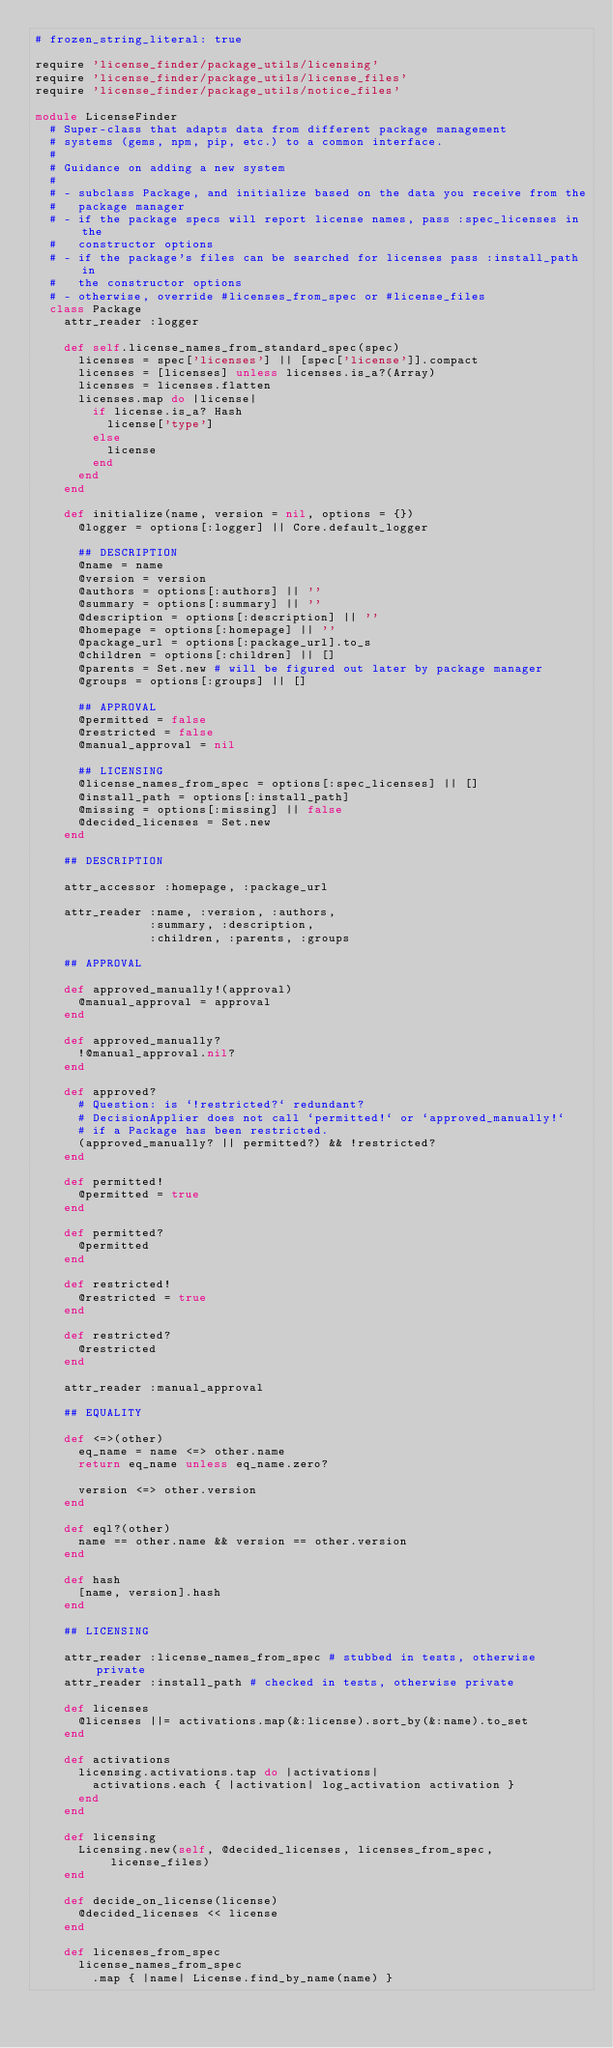Convert code to text. <code><loc_0><loc_0><loc_500><loc_500><_Ruby_># frozen_string_literal: true

require 'license_finder/package_utils/licensing'
require 'license_finder/package_utils/license_files'
require 'license_finder/package_utils/notice_files'

module LicenseFinder
  # Super-class that adapts data from different package management
  # systems (gems, npm, pip, etc.) to a common interface.
  #
  # Guidance on adding a new system
  #
  # - subclass Package, and initialize based on the data you receive from the
  #   package manager
  # - if the package specs will report license names, pass :spec_licenses in the
  #   constructor options
  # - if the package's files can be searched for licenses pass :install_path in
  #   the constructor options
  # - otherwise, override #licenses_from_spec or #license_files
  class Package
    attr_reader :logger

    def self.license_names_from_standard_spec(spec)
      licenses = spec['licenses'] || [spec['license']].compact
      licenses = [licenses] unless licenses.is_a?(Array)
      licenses = licenses.flatten
      licenses.map do |license|
        if license.is_a? Hash
          license['type']
        else
          license
        end
      end
    end

    def initialize(name, version = nil, options = {})
      @logger = options[:logger] || Core.default_logger

      ## DESCRIPTION
      @name = name
      @version = version
      @authors = options[:authors] || ''
      @summary = options[:summary] || ''
      @description = options[:description] || ''
      @homepage = options[:homepage] || ''
      @package_url = options[:package_url].to_s
      @children = options[:children] || []
      @parents = Set.new # will be figured out later by package manager
      @groups = options[:groups] || []

      ## APPROVAL
      @permitted = false
      @restricted = false
      @manual_approval = nil

      ## LICENSING
      @license_names_from_spec = options[:spec_licenses] || []
      @install_path = options[:install_path]
      @missing = options[:missing] || false
      @decided_licenses = Set.new
    end

    ## DESCRIPTION

    attr_accessor :homepage, :package_url

    attr_reader :name, :version, :authors,
                :summary, :description,
                :children, :parents, :groups

    ## APPROVAL

    def approved_manually!(approval)
      @manual_approval = approval
    end

    def approved_manually?
      !@manual_approval.nil?
    end

    def approved?
      # Question: is `!restricted?` redundant?
      # DecisionApplier does not call `permitted!` or `approved_manually!`
      # if a Package has been restricted.
      (approved_manually? || permitted?) && !restricted?
    end

    def permitted!
      @permitted = true
    end

    def permitted?
      @permitted
    end

    def restricted!
      @restricted = true
    end

    def restricted?
      @restricted
    end

    attr_reader :manual_approval

    ## EQUALITY

    def <=>(other)
      eq_name = name <=> other.name
      return eq_name unless eq_name.zero?

      version <=> other.version
    end

    def eql?(other)
      name == other.name && version == other.version
    end

    def hash
      [name, version].hash
    end

    ## LICENSING

    attr_reader :license_names_from_spec # stubbed in tests, otherwise private
    attr_reader :install_path # checked in tests, otherwise private

    def licenses
      @licenses ||= activations.map(&:license).sort_by(&:name).to_set
    end

    def activations
      licensing.activations.tap do |activations|
        activations.each { |activation| log_activation activation }
      end
    end

    def licensing
      Licensing.new(self, @decided_licenses, licenses_from_spec, license_files)
    end

    def decide_on_license(license)
      @decided_licenses << license
    end

    def licenses_from_spec
      license_names_from_spec
        .map { |name| License.find_by_name(name) }</code> 